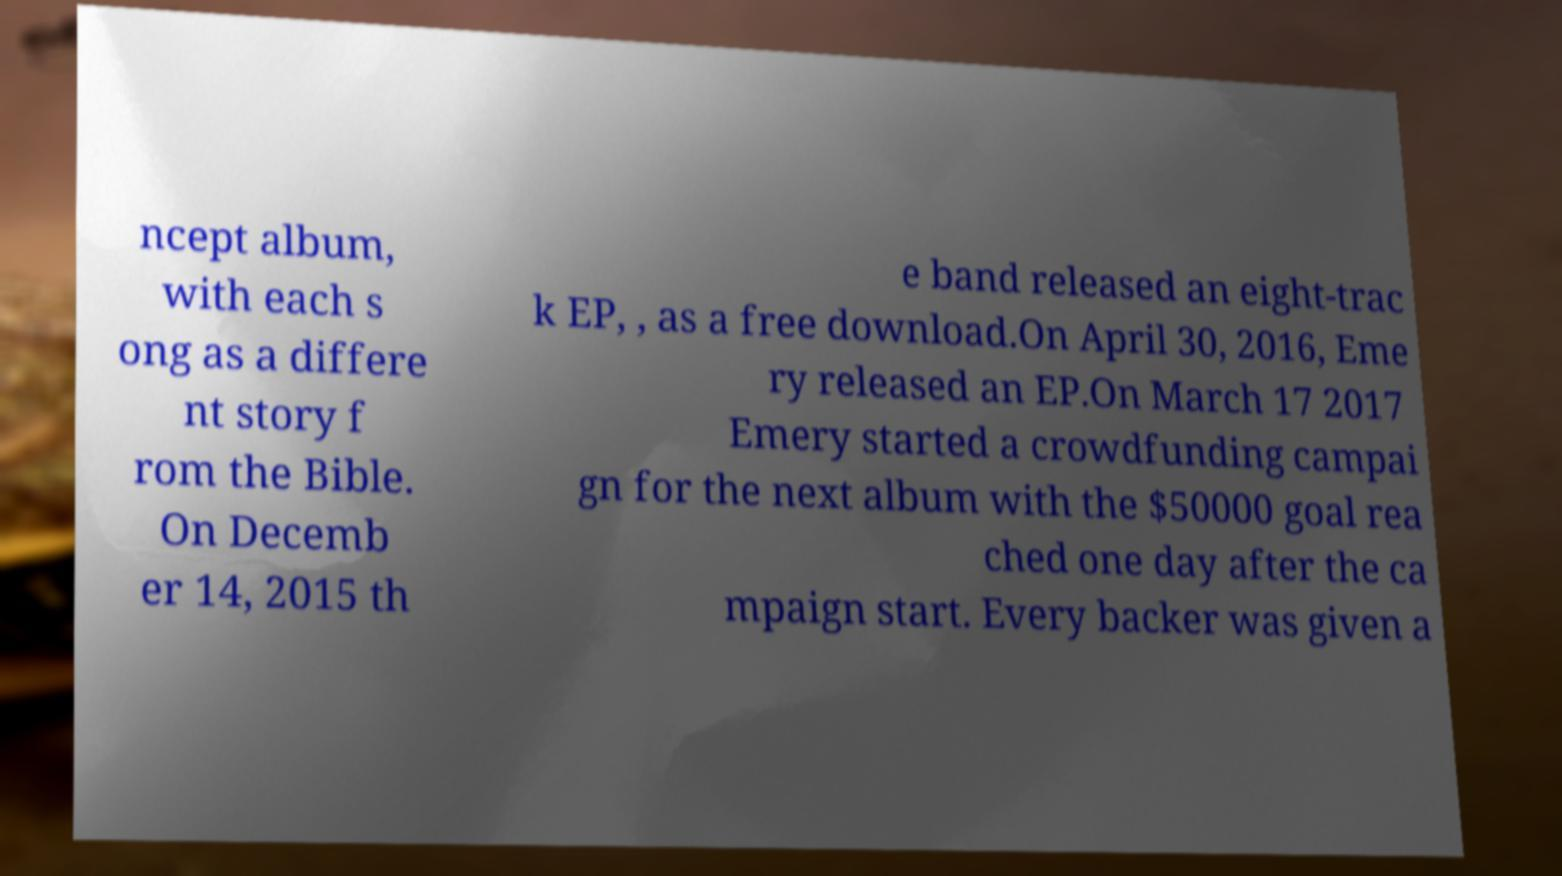Can you accurately transcribe the text from the provided image for me? ncept album, with each s ong as a differe nt story f rom the Bible. On Decemb er 14, 2015 th e band released an eight-trac k EP, , as a free download.On April 30, 2016, Eme ry released an EP.On March 17 2017 Emery started a crowdfunding campai gn for the next album with the $50000 goal rea ched one day after the ca mpaign start. Every backer was given a 